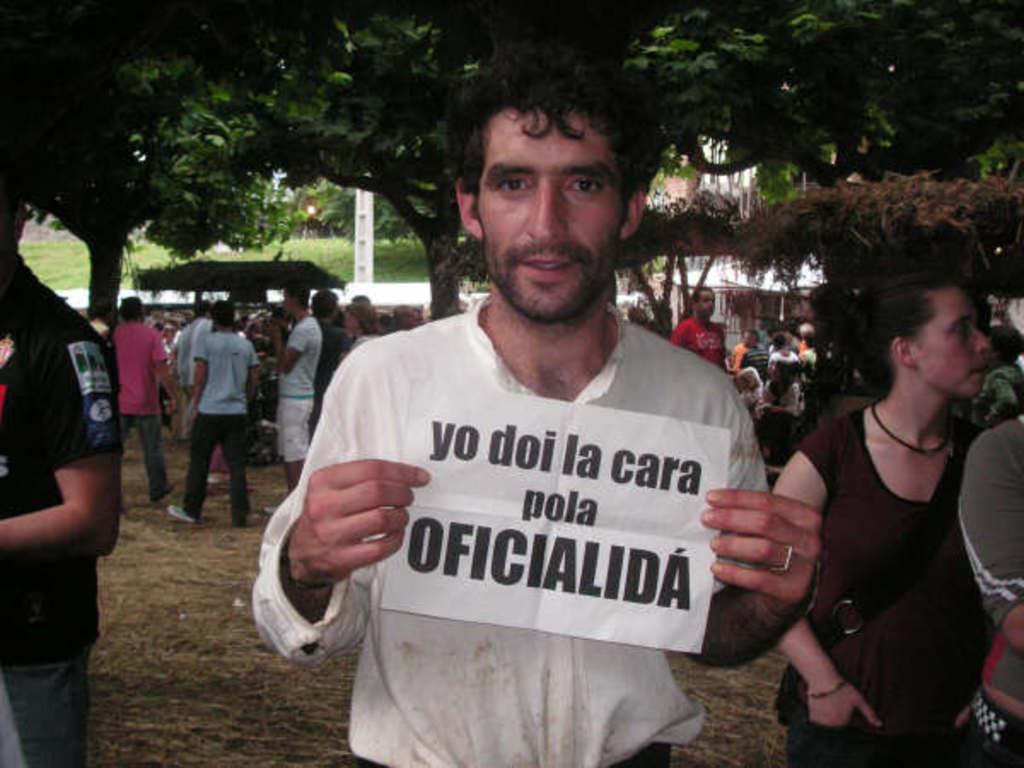Please provide a concise description of this image. In this image, in the middle there is a man, he wears a shirt, he is holding a paper. On the right there is a woman. On the left there is a man. In the background there are many people, tents, trees, grass, plants, land. 